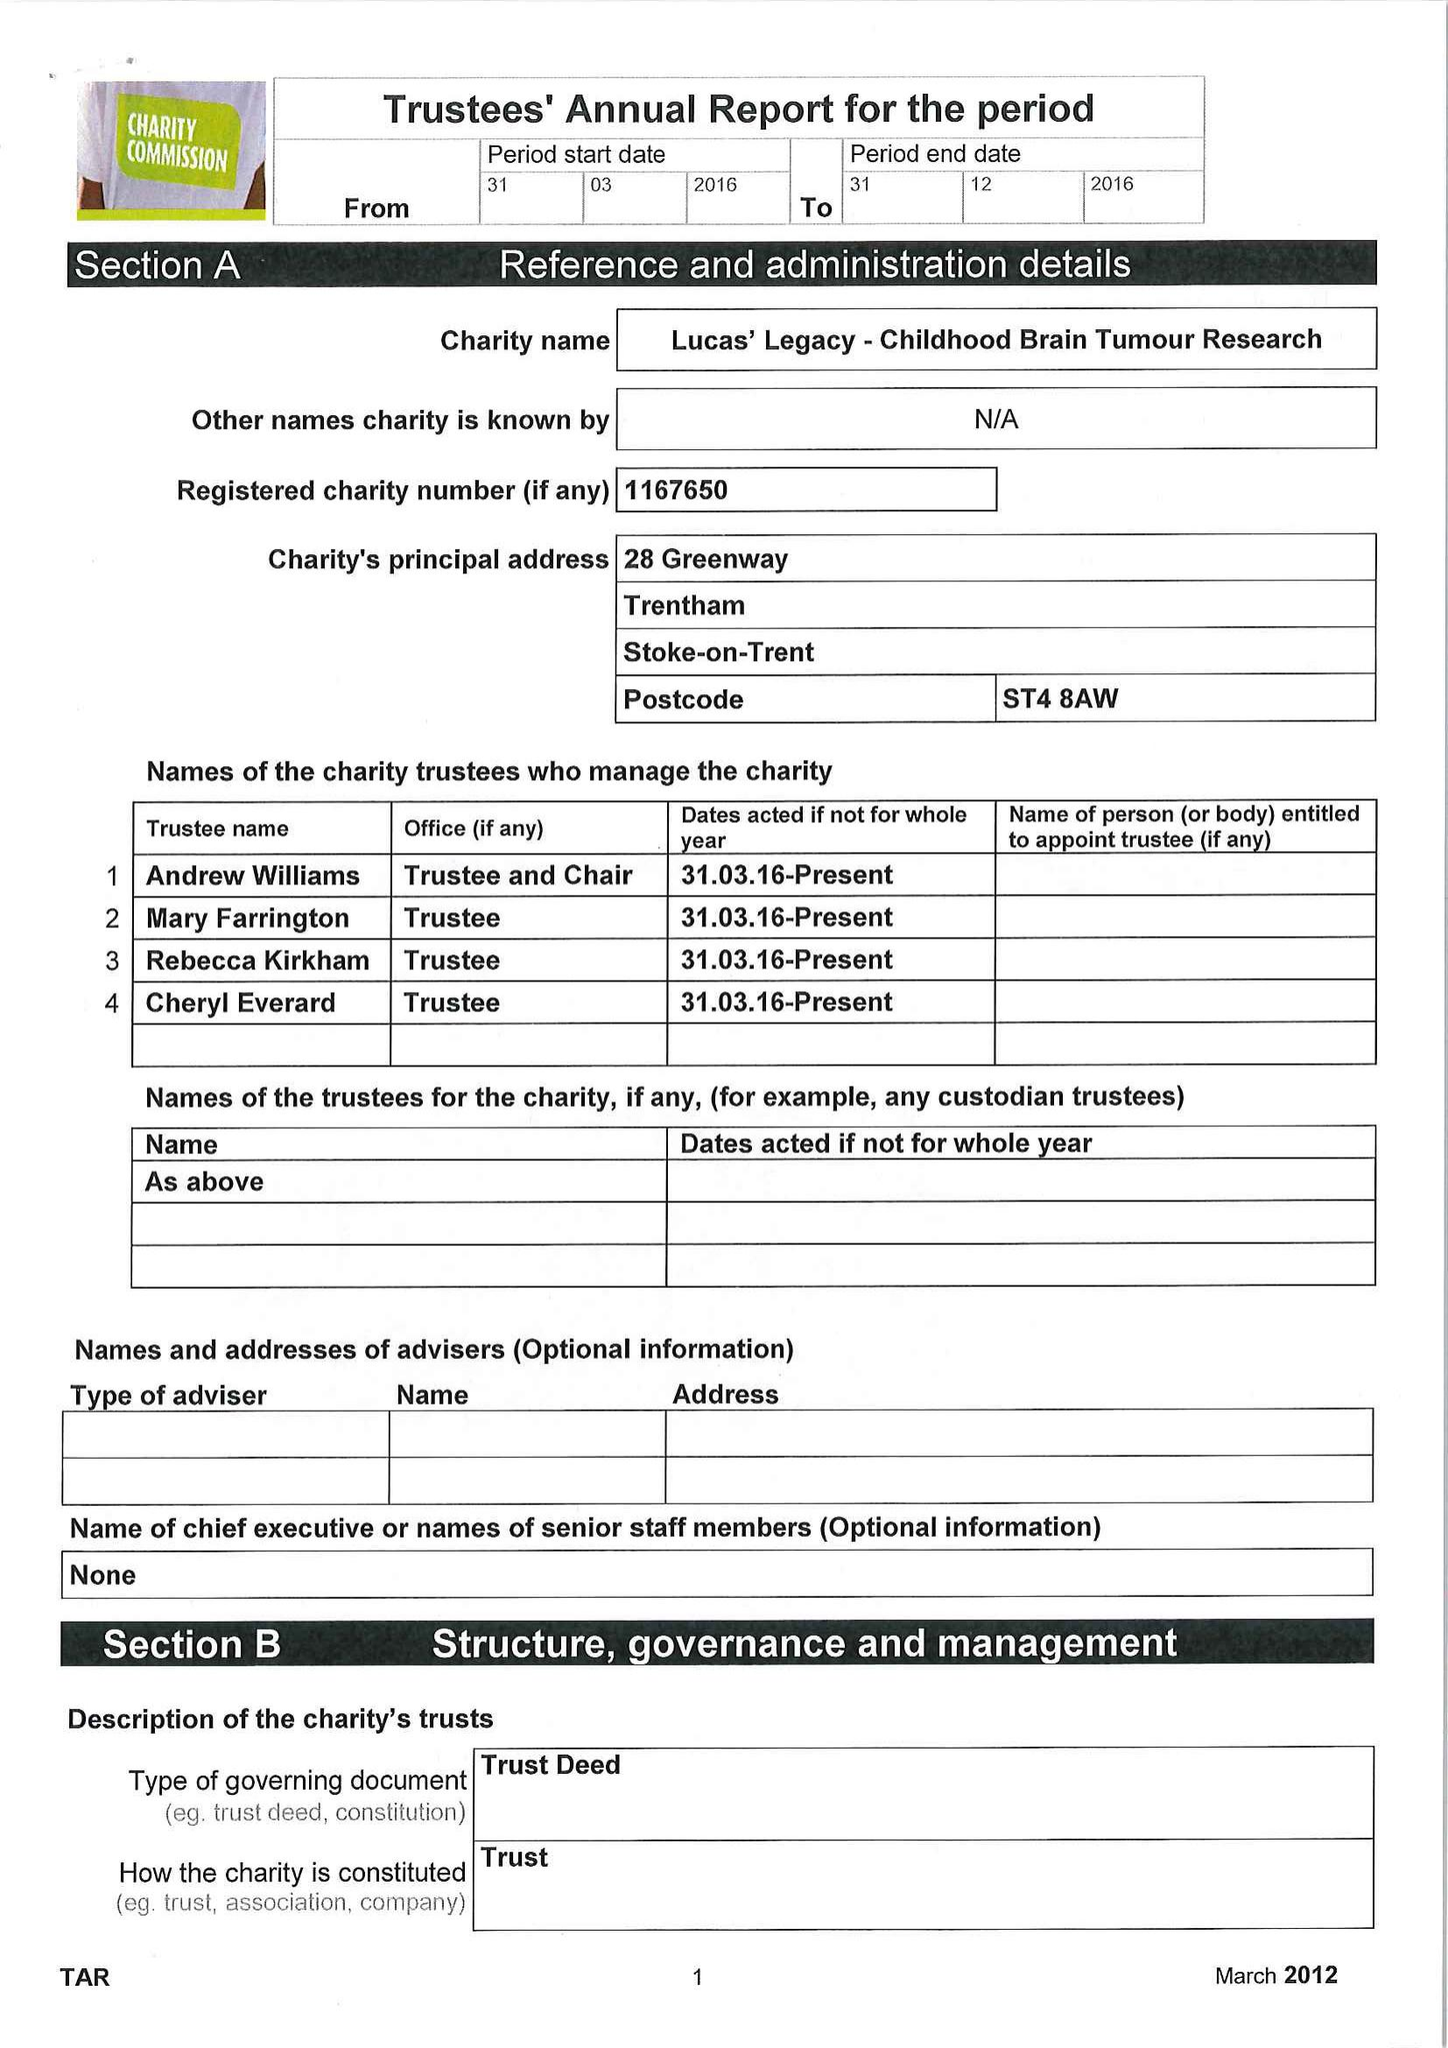What is the value for the address__street_line?
Answer the question using a single word or phrase. 28 GREENWAY 